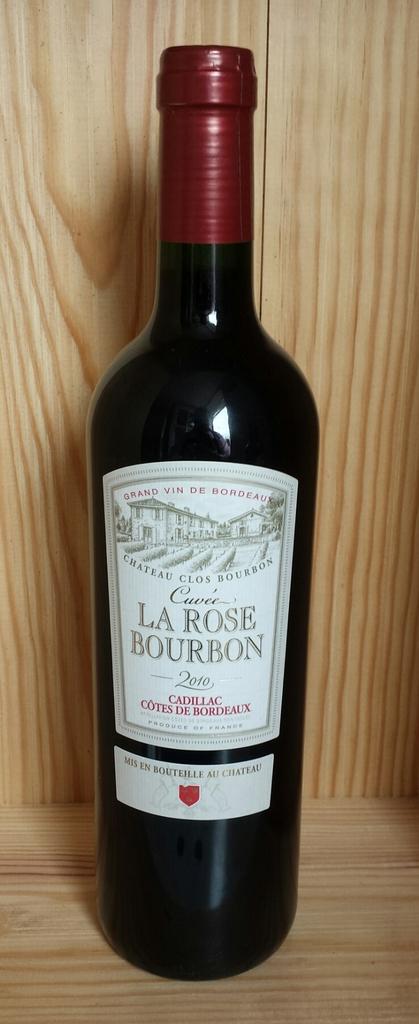What is the brand of the wine?
Make the answer very short. La rose bourbon. What type of wine is this?
Provide a short and direct response. La rose bourbon. 